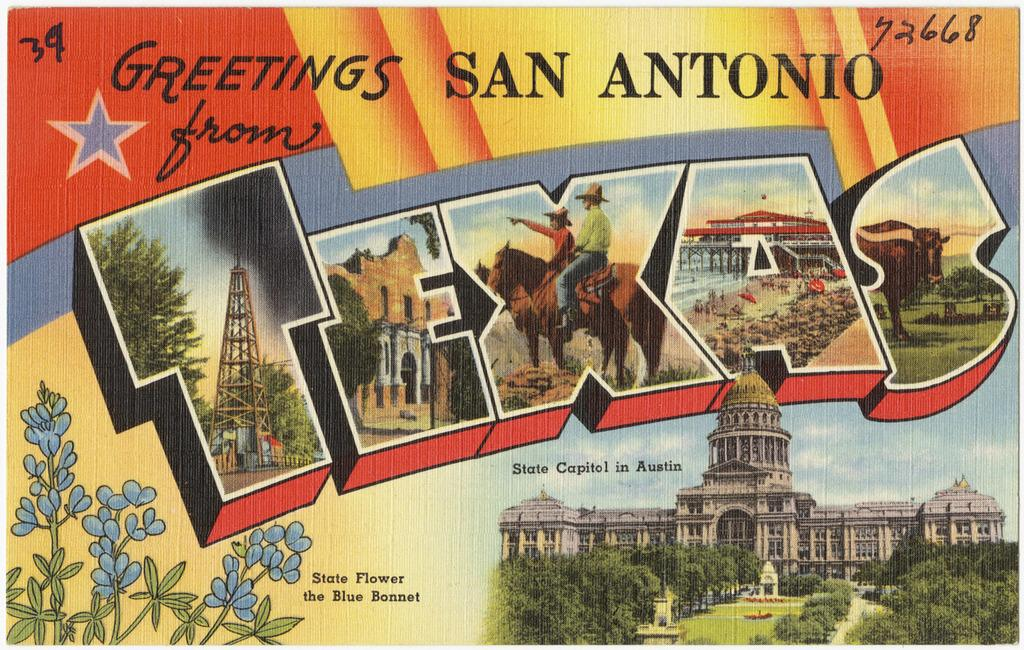What is the main subject of the image? The main subject of the image is a greeting card. What types of images are included on the greeting card? The greeting card contains pictures of buildings, trees, people, horses, and metal structures. Is there any text on the image? Yes, there is text on the image. What type of wool can be seen on the boat in the image? There is no boat or wool present in the image; it features a greeting card with various pictures and text. How does the grip of the metal structures in the image affect their stability? There is no mention of the grip or stability of the metal structures in the image; it only shows pictures of them. 